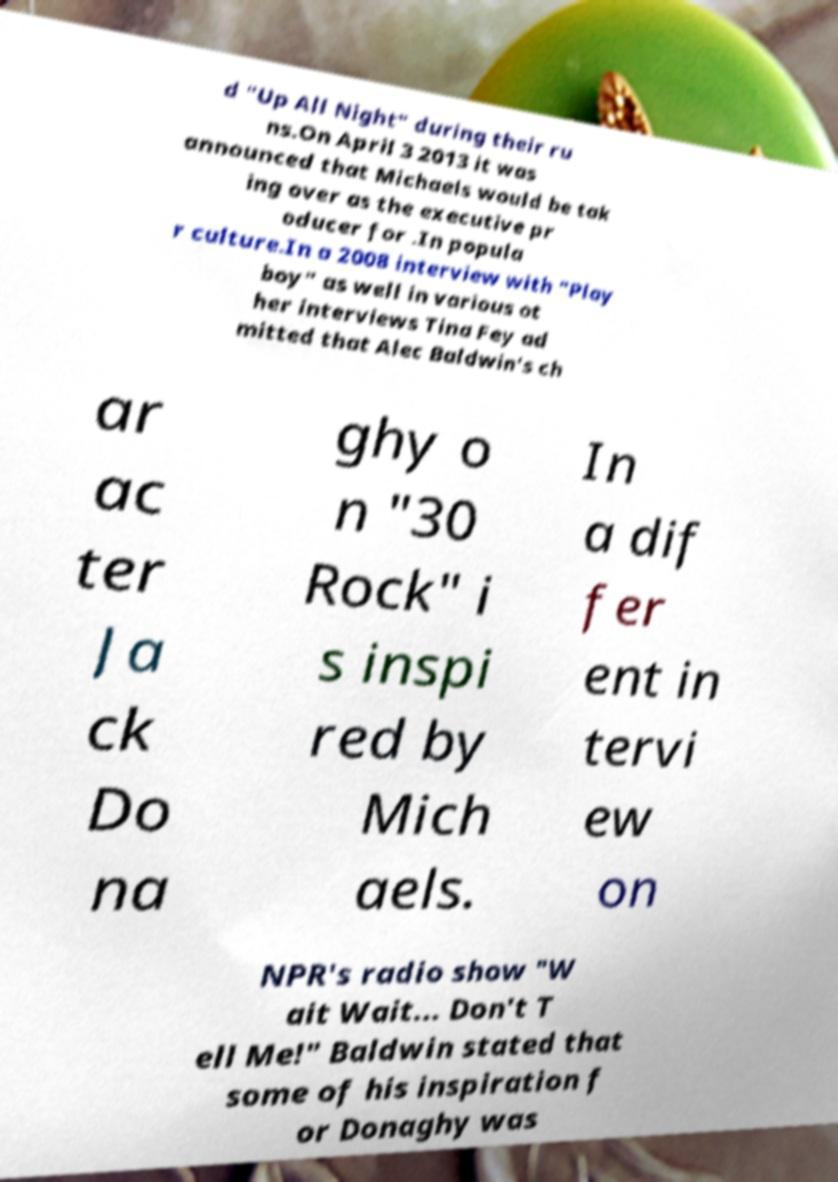Can you accurately transcribe the text from the provided image for me? d "Up All Night" during their ru ns.On April 3 2013 it was announced that Michaels would be tak ing over as the executive pr oducer for .In popula r culture.In a 2008 interview with "Play boy" as well in various ot her interviews Tina Fey ad mitted that Alec Baldwin's ch ar ac ter Ja ck Do na ghy o n "30 Rock" i s inspi red by Mich aels. In a dif fer ent in tervi ew on NPR's radio show "W ait Wait... Don't T ell Me!" Baldwin stated that some of his inspiration f or Donaghy was 